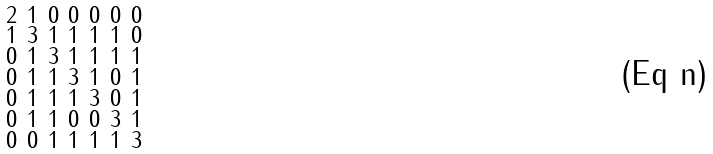Convert formula to latex. <formula><loc_0><loc_0><loc_500><loc_500>\begin{smallmatrix} 2 & 1 & 0 & 0 & 0 & 0 & 0 \\ 1 & 3 & 1 & 1 & 1 & 1 & 0 \\ 0 & 1 & 3 & 1 & 1 & 1 & 1 \\ 0 & 1 & 1 & 3 & 1 & 0 & 1 \\ 0 & 1 & 1 & 1 & 3 & 0 & 1 \\ 0 & 1 & 1 & 0 & 0 & 3 & 1 \\ 0 & 0 & 1 & 1 & 1 & 1 & 3 \end{smallmatrix}</formula> 